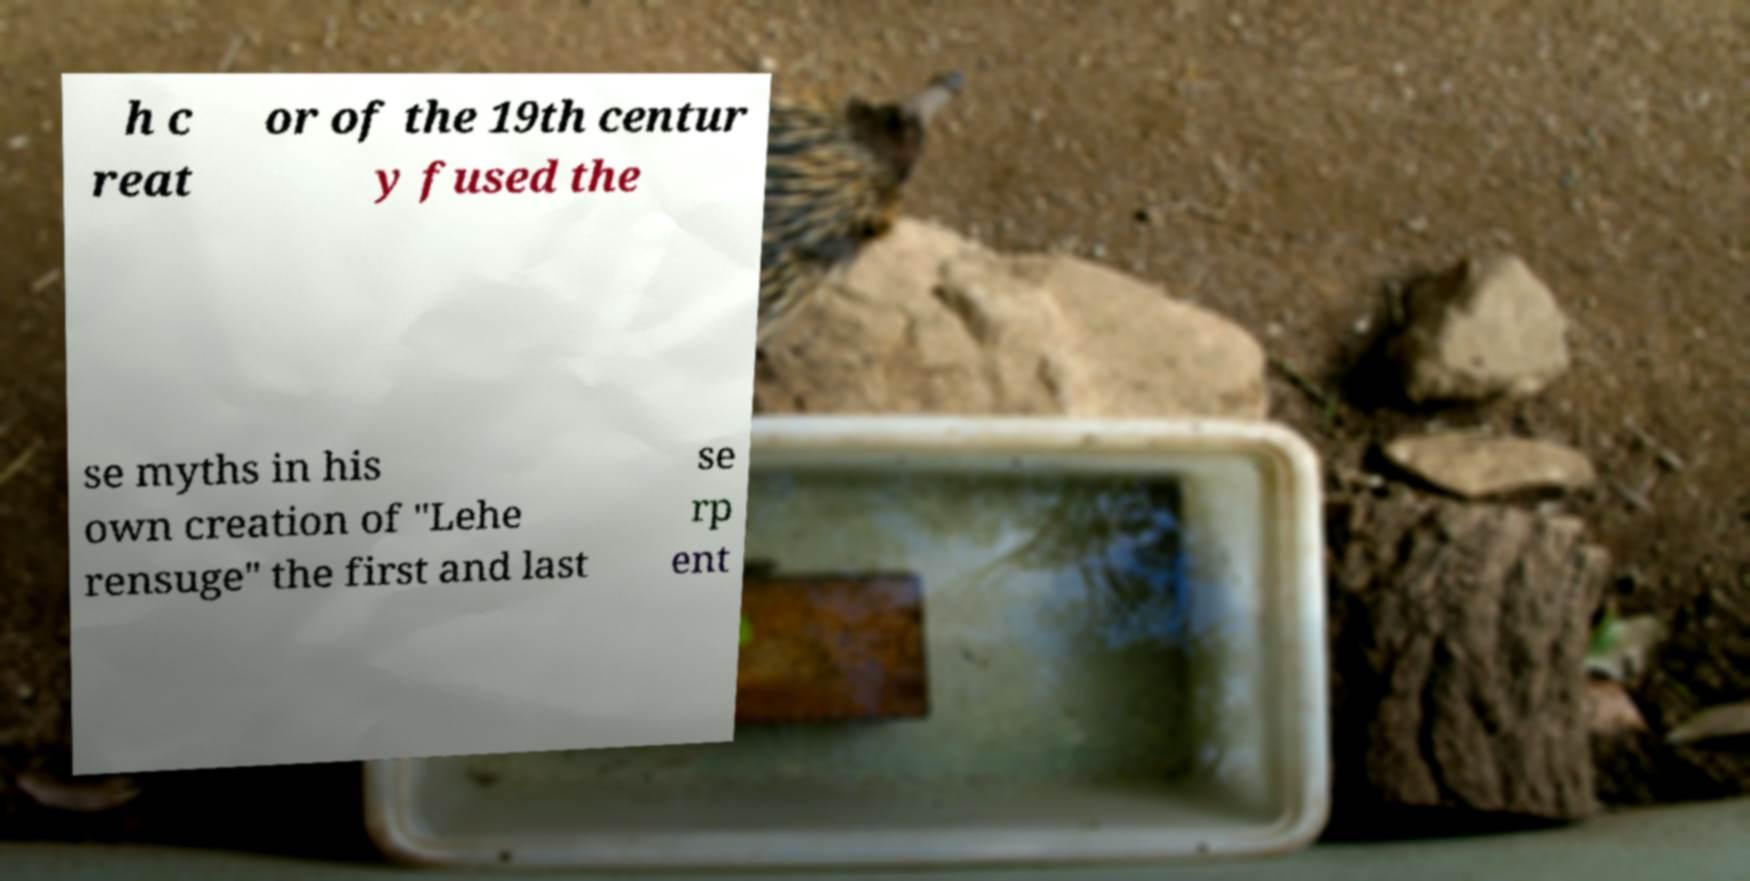I need the written content from this picture converted into text. Can you do that? h c reat or of the 19th centur y fused the se myths in his own creation of "Lehe rensuge" the first and last se rp ent 